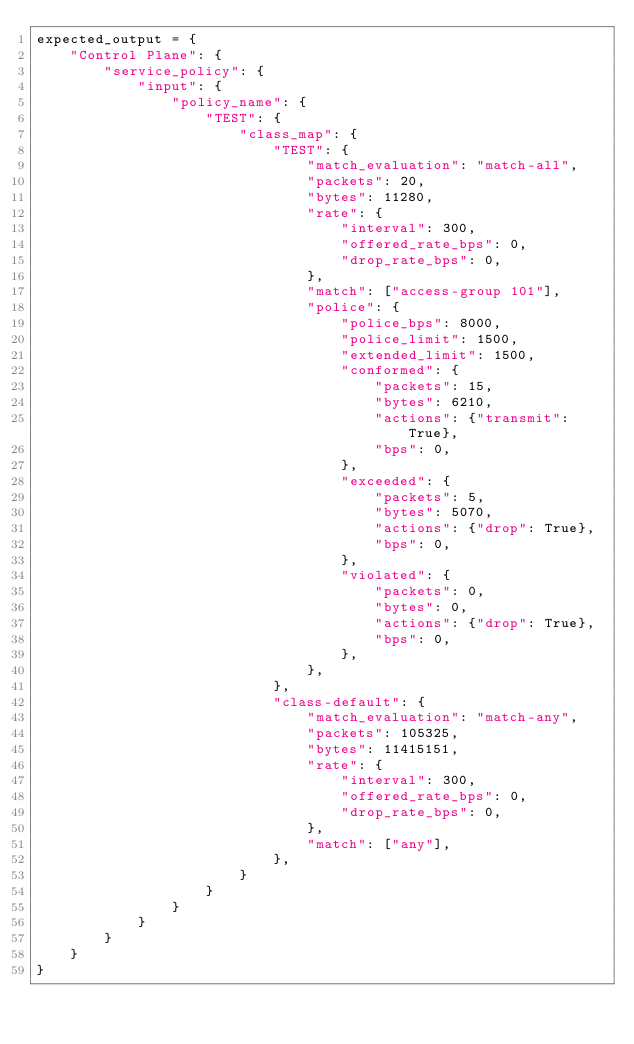Convert code to text. <code><loc_0><loc_0><loc_500><loc_500><_Python_>expected_output = {
    "Control Plane": {
        "service_policy": {
            "input": {
                "policy_name": {
                    "TEST": {
                        "class_map": {
                            "TEST": {
                                "match_evaluation": "match-all",
                                "packets": 20,
                                "bytes": 11280,
                                "rate": {
                                    "interval": 300,
                                    "offered_rate_bps": 0,
                                    "drop_rate_bps": 0,
                                },
                                "match": ["access-group 101"],
                                "police": {
                                    "police_bps": 8000,
                                    "police_limit": 1500,
                                    "extended_limit": 1500,
                                    "conformed": {
                                        "packets": 15,
                                        "bytes": 6210,
                                        "actions": {"transmit": True},
                                        "bps": 0,
                                    },
                                    "exceeded": {
                                        "packets": 5,
                                        "bytes": 5070,
                                        "actions": {"drop": True},
                                        "bps": 0,
                                    },
                                    "violated": {
                                        "packets": 0,
                                        "bytes": 0,
                                        "actions": {"drop": True},
                                        "bps": 0,
                                    },
                                },
                            },
                            "class-default": {
                                "match_evaluation": "match-any",
                                "packets": 105325,
                                "bytes": 11415151,
                                "rate": {
                                    "interval": 300,
                                    "offered_rate_bps": 0,
                                    "drop_rate_bps": 0,
                                },
                                "match": ["any"],
                            },
                        }
                    }
                }
            }
        }
    }
}
</code> 